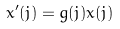<formula> <loc_0><loc_0><loc_500><loc_500>x ^ { \prime } ( j ) = g ( j ) x ( j )</formula> 